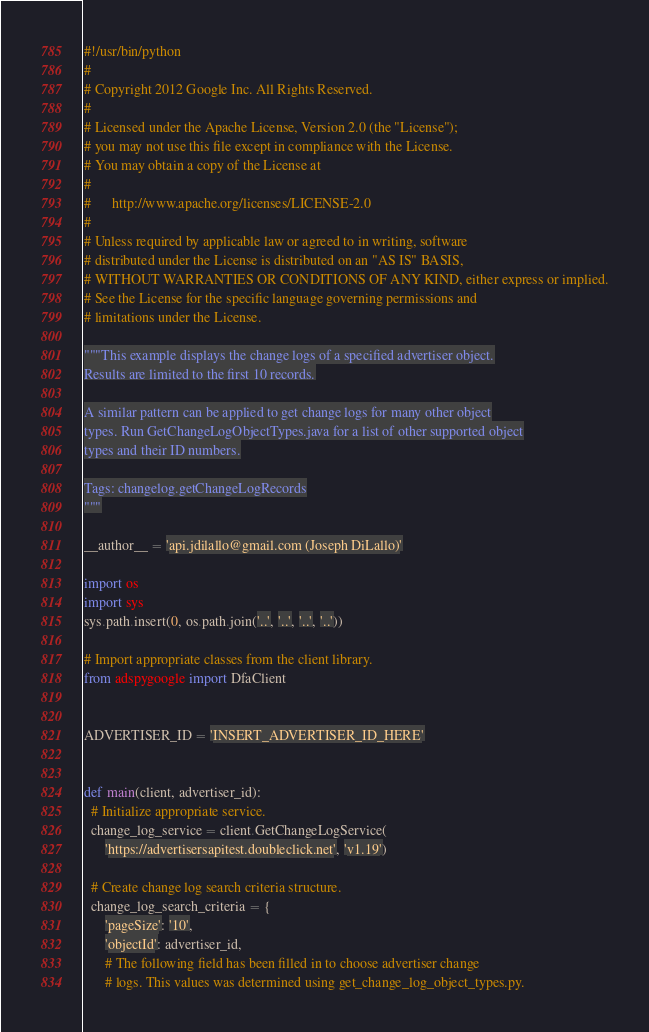Convert code to text. <code><loc_0><loc_0><loc_500><loc_500><_Python_>#!/usr/bin/python
#
# Copyright 2012 Google Inc. All Rights Reserved.
#
# Licensed under the Apache License, Version 2.0 (the "License");
# you may not use this file except in compliance with the License.
# You may obtain a copy of the License at
#
#      http://www.apache.org/licenses/LICENSE-2.0
#
# Unless required by applicable law or agreed to in writing, software
# distributed under the License is distributed on an "AS IS" BASIS,
# WITHOUT WARRANTIES OR CONDITIONS OF ANY KIND, either express or implied.
# See the License for the specific language governing permissions and
# limitations under the License.

"""This example displays the change logs of a specified advertiser object.
Results are limited to the first 10 records.

A similar pattern can be applied to get change logs for many other object
types. Run GetChangeLogObjectTypes.java for a list of other supported object
types and their ID numbers.

Tags: changelog.getChangeLogRecords
"""

__author__ = 'api.jdilallo@gmail.com (Joseph DiLallo)'

import os
import sys
sys.path.insert(0, os.path.join('..', '..', '..', '..'))

# Import appropriate classes from the client library.
from adspygoogle import DfaClient


ADVERTISER_ID = 'INSERT_ADVERTISER_ID_HERE'


def main(client, advertiser_id):
  # Initialize appropriate service.
  change_log_service = client.GetChangeLogService(
      'https://advertisersapitest.doubleclick.net', 'v1.19')

  # Create change log search criteria structure.
  change_log_search_criteria = {
      'pageSize': '10',
      'objectId': advertiser_id,
      # The following field has been filled in to choose advertiser change
      # logs. This values was determined using get_change_log_object_types.py.</code> 